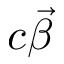Convert formula to latex. <formula><loc_0><loc_0><loc_500><loc_500>c \vec { \beta }</formula> 